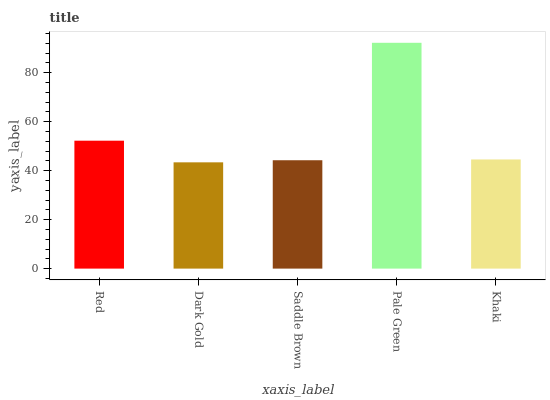Is Dark Gold the minimum?
Answer yes or no. Yes. Is Pale Green the maximum?
Answer yes or no. Yes. Is Saddle Brown the minimum?
Answer yes or no. No. Is Saddle Brown the maximum?
Answer yes or no. No. Is Saddle Brown greater than Dark Gold?
Answer yes or no. Yes. Is Dark Gold less than Saddle Brown?
Answer yes or no. Yes. Is Dark Gold greater than Saddle Brown?
Answer yes or no. No. Is Saddle Brown less than Dark Gold?
Answer yes or no. No. Is Khaki the high median?
Answer yes or no. Yes. Is Khaki the low median?
Answer yes or no. Yes. Is Pale Green the high median?
Answer yes or no. No. Is Red the low median?
Answer yes or no. No. 